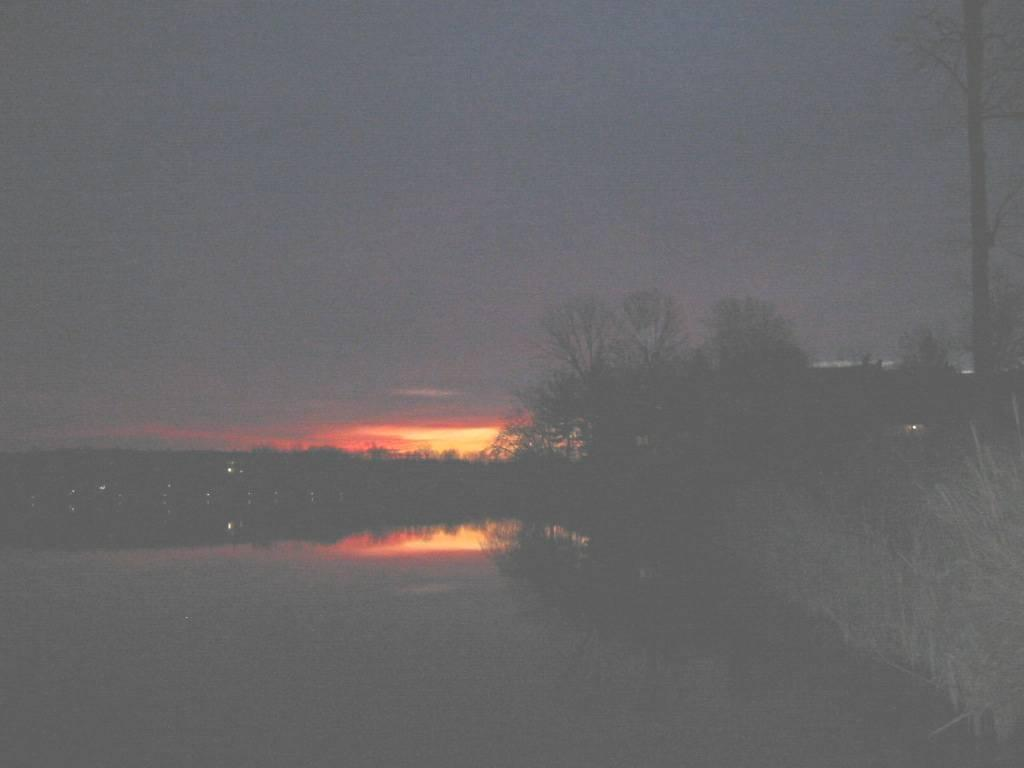What is the lighting condition in the image? The image was taken in the dark. What can be seen at the bottom of the image? There is a sea at the bottom of the image. What type of vegetation is on the right side of the image? There are trees on the right side of the image. What is visible at the top of the image? The sky is visible at the top of the image. Can you tell me where the tin is located in the image? There is no tin present in the image. What type of key is being used by the judge in the image? There is no judge or key present in the image. 